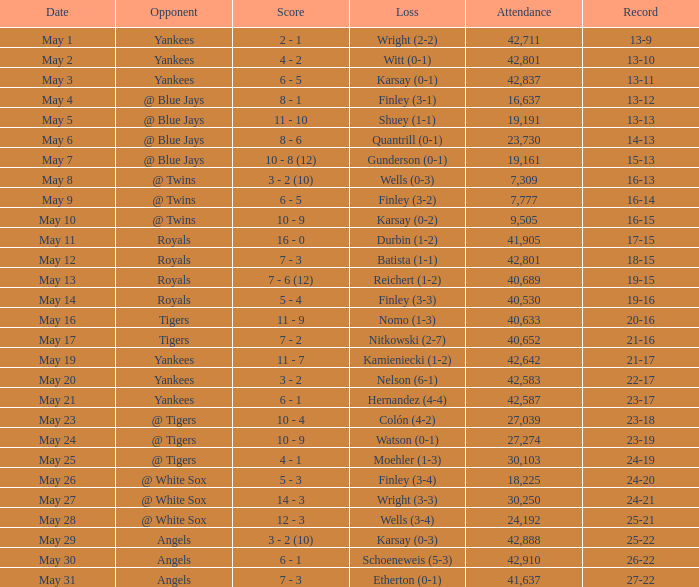What was the turnout for the game on may 25? 30103.0. 